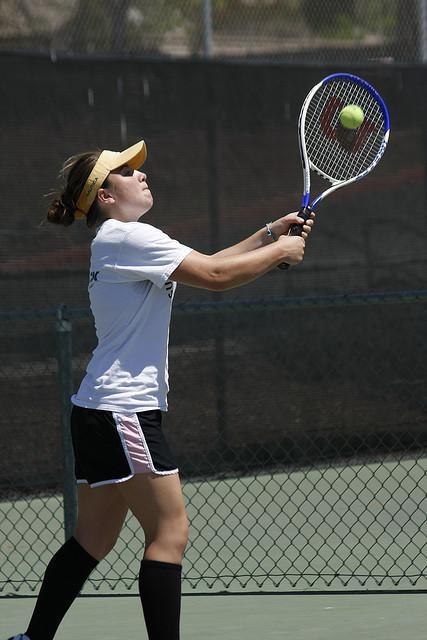What is the most common tennis racquet string material?

Choices:
A) cotton
B) nylon
C) steel
D) animal guts animal guts 